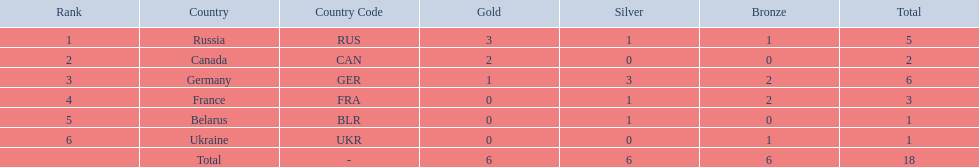What were all the countries that won biathlon medals? Russia (RUS), Canada (CAN), Germany (GER), France (FRA), Belarus (BLR), Ukraine (UKR). What were their medal counts? 5, 2, 6, 3, 1, 1. Of these, which is the largest number of medals? 6. Which country won this number of medals? Germany (GER). 